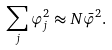Convert formula to latex. <formula><loc_0><loc_0><loc_500><loc_500>\sum _ { j } \varphi _ { j } ^ { 2 } \approx N \bar { \varphi } ^ { 2 } .</formula> 